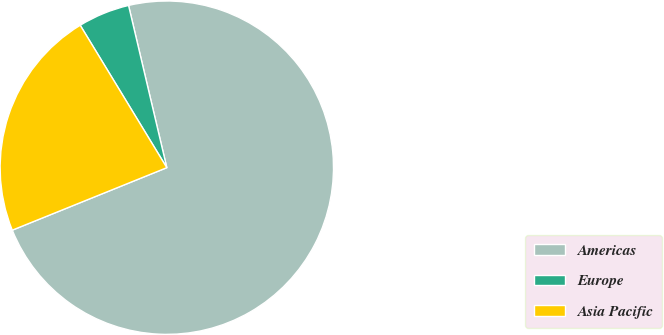<chart> <loc_0><loc_0><loc_500><loc_500><pie_chart><fcel>Americas<fcel>Europe<fcel>Asia Pacific<nl><fcel>72.57%<fcel>5.01%<fcel>22.42%<nl></chart> 